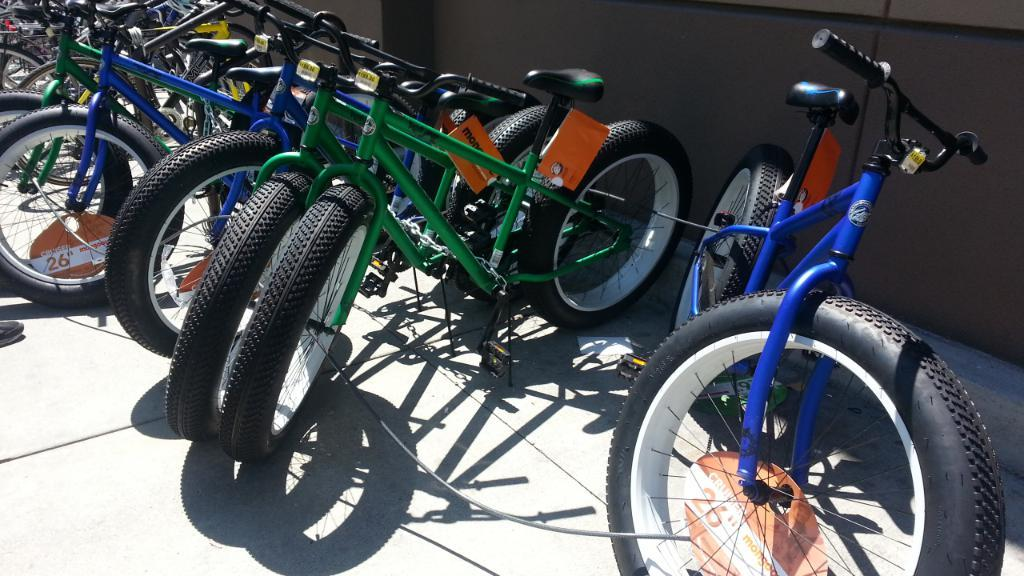What objects are on the floor in the image? There are bicycles on the floor in the image. What can be seen in the background of the image? There is a wall in the background of the image. What type of playground equipment can be seen in the image? There is no playground equipment present in the image; it features bicycles on the floor and a wall in the background. What subject is being taught in the image? There is no teaching activity depicted in the image; it simply shows bicycles on the floor and a wall in the background. 